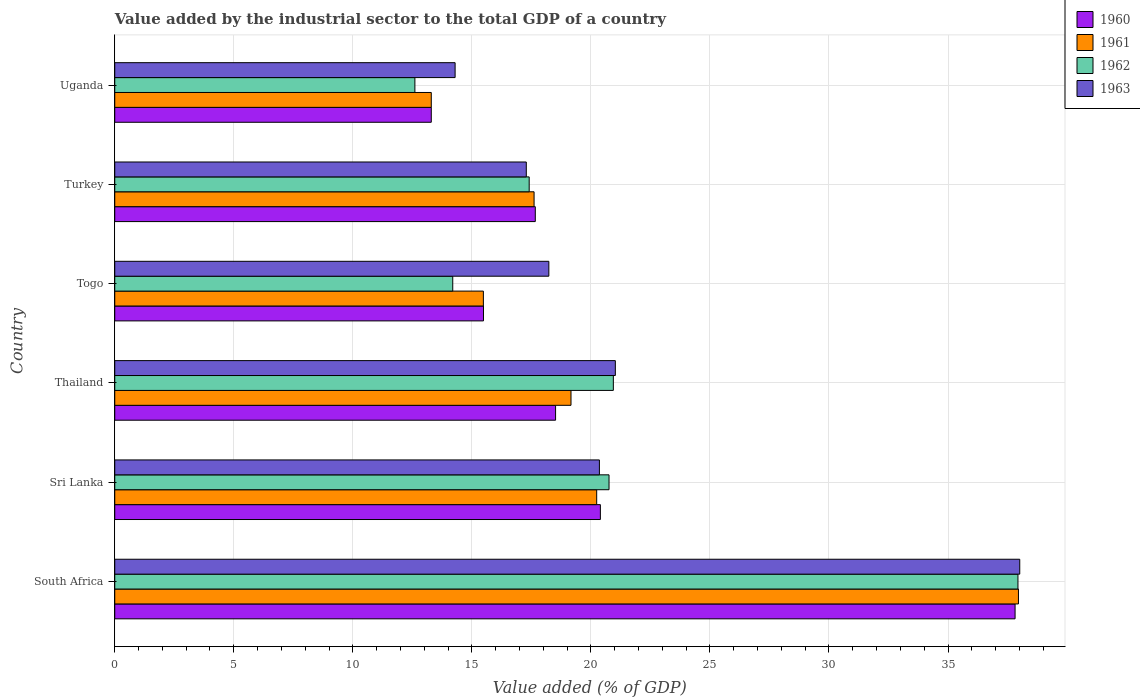How many different coloured bars are there?
Your response must be concise. 4. How many groups of bars are there?
Your answer should be compact. 6. Are the number of bars per tick equal to the number of legend labels?
Your answer should be very brief. Yes. How many bars are there on the 4th tick from the bottom?
Give a very brief answer. 4. What is the label of the 5th group of bars from the top?
Give a very brief answer. Sri Lanka. What is the value added by the industrial sector to the total GDP in 1962 in Thailand?
Your answer should be very brief. 20.94. Across all countries, what is the maximum value added by the industrial sector to the total GDP in 1961?
Provide a succinct answer. 37.96. Across all countries, what is the minimum value added by the industrial sector to the total GDP in 1960?
Your response must be concise. 13.3. In which country was the value added by the industrial sector to the total GDP in 1962 maximum?
Ensure brevity in your answer.  South Africa. In which country was the value added by the industrial sector to the total GDP in 1961 minimum?
Provide a short and direct response. Uganda. What is the total value added by the industrial sector to the total GDP in 1963 in the graph?
Give a very brief answer. 129.21. What is the difference between the value added by the industrial sector to the total GDP in 1962 in South Africa and that in Sri Lanka?
Your answer should be compact. 17.18. What is the difference between the value added by the industrial sector to the total GDP in 1960 in Sri Lanka and the value added by the industrial sector to the total GDP in 1961 in South Africa?
Ensure brevity in your answer.  -17.56. What is the average value added by the industrial sector to the total GDP in 1960 per country?
Your answer should be compact. 20.53. What is the difference between the value added by the industrial sector to the total GDP in 1963 and value added by the industrial sector to the total GDP in 1962 in Togo?
Provide a short and direct response. 4.04. What is the ratio of the value added by the industrial sector to the total GDP in 1963 in Thailand to that in Uganda?
Offer a very short reply. 1.47. What is the difference between the highest and the second highest value added by the industrial sector to the total GDP in 1962?
Ensure brevity in your answer.  17. What is the difference between the highest and the lowest value added by the industrial sector to the total GDP in 1962?
Your answer should be very brief. 25.33. Is the sum of the value added by the industrial sector to the total GDP in 1960 in South Africa and Thailand greater than the maximum value added by the industrial sector to the total GDP in 1962 across all countries?
Ensure brevity in your answer.  Yes. Is it the case that in every country, the sum of the value added by the industrial sector to the total GDP in 1960 and value added by the industrial sector to the total GDP in 1963 is greater than the sum of value added by the industrial sector to the total GDP in 1962 and value added by the industrial sector to the total GDP in 1961?
Your answer should be compact. No. What does the 2nd bar from the bottom in Turkey represents?
Your response must be concise. 1961. Is it the case that in every country, the sum of the value added by the industrial sector to the total GDP in 1961 and value added by the industrial sector to the total GDP in 1963 is greater than the value added by the industrial sector to the total GDP in 1960?
Make the answer very short. Yes. How many bars are there?
Your response must be concise. 24. Are all the bars in the graph horizontal?
Your answer should be compact. Yes. How many countries are there in the graph?
Make the answer very short. 6. Are the values on the major ticks of X-axis written in scientific E-notation?
Make the answer very short. No. Does the graph contain grids?
Provide a short and direct response. Yes. How are the legend labels stacked?
Ensure brevity in your answer.  Vertical. What is the title of the graph?
Your answer should be compact. Value added by the industrial sector to the total GDP of a country. What is the label or title of the X-axis?
Your response must be concise. Value added (% of GDP). What is the label or title of the Y-axis?
Your answer should be compact. Country. What is the Value added (% of GDP) in 1960 in South Africa?
Give a very brief answer. 37.82. What is the Value added (% of GDP) in 1961 in South Africa?
Your response must be concise. 37.96. What is the Value added (% of GDP) in 1962 in South Africa?
Give a very brief answer. 37.94. What is the Value added (% of GDP) in 1963 in South Africa?
Your answer should be compact. 38.01. What is the Value added (% of GDP) in 1960 in Sri Lanka?
Your answer should be compact. 20.4. What is the Value added (% of GDP) in 1961 in Sri Lanka?
Your answer should be compact. 20.24. What is the Value added (% of GDP) in 1962 in Sri Lanka?
Make the answer very short. 20.76. What is the Value added (% of GDP) in 1963 in Sri Lanka?
Offer a terse response. 20.36. What is the Value added (% of GDP) in 1960 in Thailand?
Give a very brief answer. 18.52. What is the Value added (% of GDP) of 1961 in Thailand?
Offer a terse response. 19.16. What is the Value added (% of GDP) in 1962 in Thailand?
Give a very brief answer. 20.94. What is the Value added (% of GDP) in 1963 in Thailand?
Ensure brevity in your answer.  21.03. What is the Value added (% of GDP) of 1960 in Togo?
Your answer should be very brief. 15.49. What is the Value added (% of GDP) in 1961 in Togo?
Keep it short and to the point. 15.48. What is the Value added (% of GDP) of 1962 in Togo?
Provide a succinct answer. 14.2. What is the Value added (% of GDP) in 1963 in Togo?
Offer a terse response. 18.23. What is the Value added (% of GDP) of 1960 in Turkey?
Your response must be concise. 17.66. What is the Value added (% of GDP) of 1961 in Turkey?
Provide a succinct answer. 17.61. What is the Value added (% of GDP) of 1962 in Turkey?
Keep it short and to the point. 17.41. What is the Value added (% of GDP) of 1963 in Turkey?
Offer a terse response. 17.29. What is the Value added (% of GDP) in 1960 in Uganda?
Make the answer very short. 13.3. What is the Value added (% of GDP) in 1961 in Uganda?
Offer a very short reply. 13.3. What is the Value added (% of GDP) of 1962 in Uganda?
Offer a very short reply. 12.61. What is the Value added (% of GDP) of 1963 in Uganda?
Your answer should be very brief. 14.3. Across all countries, what is the maximum Value added (% of GDP) in 1960?
Offer a very short reply. 37.82. Across all countries, what is the maximum Value added (% of GDP) in 1961?
Give a very brief answer. 37.96. Across all countries, what is the maximum Value added (% of GDP) in 1962?
Offer a very short reply. 37.94. Across all countries, what is the maximum Value added (% of GDP) of 1963?
Provide a succinct answer. 38.01. Across all countries, what is the minimum Value added (% of GDP) of 1960?
Provide a short and direct response. 13.3. Across all countries, what is the minimum Value added (% of GDP) of 1961?
Ensure brevity in your answer.  13.3. Across all countries, what is the minimum Value added (% of GDP) of 1962?
Provide a short and direct response. 12.61. Across all countries, what is the minimum Value added (% of GDP) of 1963?
Keep it short and to the point. 14.3. What is the total Value added (% of GDP) in 1960 in the graph?
Your response must be concise. 123.18. What is the total Value added (% of GDP) of 1961 in the graph?
Your answer should be very brief. 123.76. What is the total Value added (% of GDP) in 1962 in the graph?
Your response must be concise. 123.86. What is the total Value added (% of GDP) of 1963 in the graph?
Offer a terse response. 129.21. What is the difference between the Value added (% of GDP) in 1960 in South Africa and that in Sri Lanka?
Keep it short and to the point. 17.42. What is the difference between the Value added (% of GDP) in 1961 in South Africa and that in Sri Lanka?
Give a very brief answer. 17.72. What is the difference between the Value added (% of GDP) of 1962 in South Africa and that in Sri Lanka?
Provide a succinct answer. 17.18. What is the difference between the Value added (% of GDP) of 1963 in South Africa and that in Sri Lanka?
Your answer should be very brief. 17.66. What is the difference between the Value added (% of GDP) of 1960 in South Africa and that in Thailand?
Provide a short and direct response. 19.3. What is the difference between the Value added (% of GDP) of 1961 in South Africa and that in Thailand?
Make the answer very short. 18.79. What is the difference between the Value added (% of GDP) in 1962 in South Africa and that in Thailand?
Offer a terse response. 17. What is the difference between the Value added (% of GDP) of 1963 in South Africa and that in Thailand?
Provide a short and direct response. 16.99. What is the difference between the Value added (% of GDP) of 1960 in South Africa and that in Togo?
Provide a succinct answer. 22.33. What is the difference between the Value added (% of GDP) in 1961 in South Africa and that in Togo?
Keep it short and to the point. 22.48. What is the difference between the Value added (% of GDP) in 1962 in South Africa and that in Togo?
Provide a succinct answer. 23.74. What is the difference between the Value added (% of GDP) of 1963 in South Africa and that in Togo?
Offer a terse response. 19.78. What is the difference between the Value added (% of GDP) of 1960 in South Africa and that in Turkey?
Your answer should be very brief. 20.15. What is the difference between the Value added (% of GDP) in 1961 in South Africa and that in Turkey?
Offer a very short reply. 20.35. What is the difference between the Value added (% of GDP) of 1962 in South Africa and that in Turkey?
Keep it short and to the point. 20.53. What is the difference between the Value added (% of GDP) of 1963 in South Africa and that in Turkey?
Your response must be concise. 20.73. What is the difference between the Value added (% of GDP) of 1960 in South Africa and that in Uganda?
Keep it short and to the point. 24.52. What is the difference between the Value added (% of GDP) in 1961 in South Africa and that in Uganda?
Ensure brevity in your answer.  24.66. What is the difference between the Value added (% of GDP) of 1962 in South Africa and that in Uganda?
Provide a succinct answer. 25.33. What is the difference between the Value added (% of GDP) of 1963 in South Africa and that in Uganda?
Ensure brevity in your answer.  23.72. What is the difference between the Value added (% of GDP) of 1960 in Sri Lanka and that in Thailand?
Make the answer very short. 1.88. What is the difference between the Value added (% of GDP) in 1961 in Sri Lanka and that in Thailand?
Your answer should be very brief. 1.08. What is the difference between the Value added (% of GDP) of 1962 in Sri Lanka and that in Thailand?
Ensure brevity in your answer.  -0.18. What is the difference between the Value added (% of GDP) in 1963 in Sri Lanka and that in Thailand?
Offer a terse response. -0.67. What is the difference between the Value added (% of GDP) of 1960 in Sri Lanka and that in Togo?
Keep it short and to the point. 4.91. What is the difference between the Value added (% of GDP) in 1961 in Sri Lanka and that in Togo?
Offer a terse response. 4.76. What is the difference between the Value added (% of GDP) in 1962 in Sri Lanka and that in Togo?
Offer a very short reply. 6.56. What is the difference between the Value added (% of GDP) in 1963 in Sri Lanka and that in Togo?
Offer a very short reply. 2.12. What is the difference between the Value added (% of GDP) in 1960 in Sri Lanka and that in Turkey?
Your answer should be compact. 2.73. What is the difference between the Value added (% of GDP) of 1961 in Sri Lanka and that in Turkey?
Make the answer very short. 2.63. What is the difference between the Value added (% of GDP) of 1962 in Sri Lanka and that in Turkey?
Your answer should be compact. 3.35. What is the difference between the Value added (% of GDP) of 1963 in Sri Lanka and that in Turkey?
Offer a very short reply. 3.07. What is the difference between the Value added (% of GDP) in 1960 in Sri Lanka and that in Uganda?
Provide a succinct answer. 7.1. What is the difference between the Value added (% of GDP) of 1961 in Sri Lanka and that in Uganda?
Your response must be concise. 6.95. What is the difference between the Value added (% of GDP) in 1962 in Sri Lanka and that in Uganda?
Offer a terse response. 8.15. What is the difference between the Value added (% of GDP) in 1963 in Sri Lanka and that in Uganda?
Ensure brevity in your answer.  6.06. What is the difference between the Value added (% of GDP) in 1960 in Thailand and that in Togo?
Provide a short and direct response. 3.03. What is the difference between the Value added (% of GDP) of 1961 in Thailand and that in Togo?
Provide a short and direct response. 3.68. What is the difference between the Value added (% of GDP) of 1962 in Thailand and that in Togo?
Keep it short and to the point. 6.75. What is the difference between the Value added (% of GDP) in 1963 in Thailand and that in Togo?
Ensure brevity in your answer.  2.79. What is the difference between the Value added (% of GDP) in 1960 in Thailand and that in Turkey?
Offer a very short reply. 0.85. What is the difference between the Value added (% of GDP) in 1961 in Thailand and that in Turkey?
Your answer should be very brief. 1.55. What is the difference between the Value added (% of GDP) in 1962 in Thailand and that in Turkey?
Make the answer very short. 3.54. What is the difference between the Value added (% of GDP) of 1963 in Thailand and that in Turkey?
Ensure brevity in your answer.  3.74. What is the difference between the Value added (% of GDP) of 1960 in Thailand and that in Uganda?
Provide a succinct answer. 5.22. What is the difference between the Value added (% of GDP) in 1961 in Thailand and that in Uganda?
Give a very brief answer. 5.87. What is the difference between the Value added (% of GDP) of 1962 in Thailand and that in Uganda?
Your answer should be very brief. 8.34. What is the difference between the Value added (% of GDP) in 1963 in Thailand and that in Uganda?
Give a very brief answer. 6.73. What is the difference between the Value added (% of GDP) in 1960 in Togo and that in Turkey?
Ensure brevity in your answer.  -2.18. What is the difference between the Value added (% of GDP) in 1961 in Togo and that in Turkey?
Offer a very short reply. -2.13. What is the difference between the Value added (% of GDP) in 1962 in Togo and that in Turkey?
Provide a succinct answer. -3.21. What is the difference between the Value added (% of GDP) in 1963 in Togo and that in Turkey?
Your response must be concise. 0.95. What is the difference between the Value added (% of GDP) of 1960 in Togo and that in Uganda?
Give a very brief answer. 2.19. What is the difference between the Value added (% of GDP) in 1961 in Togo and that in Uganda?
Make the answer very short. 2.19. What is the difference between the Value added (% of GDP) in 1962 in Togo and that in Uganda?
Provide a short and direct response. 1.59. What is the difference between the Value added (% of GDP) in 1963 in Togo and that in Uganda?
Provide a short and direct response. 3.94. What is the difference between the Value added (% of GDP) in 1960 in Turkey and that in Uganda?
Your response must be concise. 4.37. What is the difference between the Value added (% of GDP) of 1961 in Turkey and that in Uganda?
Give a very brief answer. 4.32. What is the difference between the Value added (% of GDP) of 1962 in Turkey and that in Uganda?
Your answer should be compact. 4.8. What is the difference between the Value added (% of GDP) of 1963 in Turkey and that in Uganda?
Give a very brief answer. 2.99. What is the difference between the Value added (% of GDP) in 1960 in South Africa and the Value added (% of GDP) in 1961 in Sri Lanka?
Offer a terse response. 17.57. What is the difference between the Value added (% of GDP) of 1960 in South Africa and the Value added (% of GDP) of 1962 in Sri Lanka?
Make the answer very short. 17.06. What is the difference between the Value added (% of GDP) of 1960 in South Africa and the Value added (% of GDP) of 1963 in Sri Lanka?
Offer a very short reply. 17.46. What is the difference between the Value added (% of GDP) of 1961 in South Africa and the Value added (% of GDP) of 1962 in Sri Lanka?
Give a very brief answer. 17.2. What is the difference between the Value added (% of GDP) of 1961 in South Africa and the Value added (% of GDP) of 1963 in Sri Lanka?
Your response must be concise. 17.6. What is the difference between the Value added (% of GDP) of 1962 in South Africa and the Value added (% of GDP) of 1963 in Sri Lanka?
Make the answer very short. 17.58. What is the difference between the Value added (% of GDP) in 1960 in South Africa and the Value added (% of GDP) in 1961 in Thailand?
Ensure brevity in your answer.  18.65. What is the difference between the Value added (% of GDP) in 1960 in South Africa and the Value added (% of GDP) in 1962 in Thailand?
Your response must be concise. 16.87. What is the difference between the Value added (% of GDP) of 1960 in South Africa and the Value added (% of GDP) of 1963 in Thailand?
Provide a short and direct response. 16.79. What is the difference between the Value added (% of GDP) in 1961 in South Africa and the Value added (% of GDP) in 1962 in Thailand?
Keep it short and to the point. 17.02. What is the difference between the Value added (% of GDP) in 1961 in South Africa and the Value added (% of GDP) in 1963 in Thailand?
Your response must be concise. 16.93. What is the difference between the Value added (% of GDP) in 1962 in South Africa and the Value added (% of GDP) in 1963 in Thailand?
Your answer should be compact. 16.91. What is the difference between the Value added (% of GDP) of 1960 in South Africa and the Value added (% of GDP) of 1961 in Togo?
Your response must be concise. 22.33. What is the difference between the Value added (% of GDP) in 1960 in South Africa and the Value added (% of GDP) in 1962 in Togo?
Your answer should be compact. 23.62. What is the difference between the Value added (% of GDP) of 1960 in South Africa and the Value added (% of GDP) of 1963 in Togo?
Keep it short and to the point. 19.58. What is the difference between the Value added (% of GDP) of 1961 in South Africa and the Value added (% of GDP) of 1962 in Togo?
Provide a succinct answer. 23.76. What is the difference between the Value added (% of GDP) in 1961 in South Africa and the Value added (% of GDP) in 1963 in Togo?
Keep it short and to the point. 19.73. What is the difference between the Value added (% of GDP) of 1962 in South Africa and the Value added (% of GDP) of 1963 in Togo?
Offer a very short reply. 19.7. What is the difference between the Value added (% of GDP) of 1960 in South Africa and the Value added (% of GDP) of 1961 in Turkey?
Provide a short and direct response. 20.2. What is the difference between the Value added (% of GDP) in 1960 in South Africa and the Value added (% of GDP) in 1962 in Turkey?
Provide a succinct answer. 20.41. What is the difference between the Value added (% of GDP) in 1960 in South Africa and the Value added (% of GDP) in 1963 in Turkey?
Offer a terse response. 20.53. What is the difference between the Value added (% of GDP) in 1961 in South Africa and the Value added (% of GDP) in 1962 in Turkey?
Your answer should be compact. 20.55. What is the difference between the Value added (% of GDP) of 1961 in South Africa and the Value added (% of GDP) of 1963 in Turkey?
Ensure brevity in your answer.  20.67. What is the difference between the Value added (% of GDP) in 1962 in South Africa and the Value added (% of GDP) in 1963 in Turkey?
Your response must be concise. 20.65. What is the difference between the Value added (% of GDP) of 1960 in South Africa and the Value added (% of GDP) of 1961 in Uganda?
Offer a terse response. 24.52. What is the difference between the Value added (% of GDP) of 1960 in South Africa and the Value added (% of GDP) of 1962 in Uganda?
Provide a succinct answer. 25.21. What is the difference between the Value added (% of GDP) in 1960 in South Africa and the Value added (% of GDP) in 1963 in Uganda?
Your answer should be compact. 23.52. What is the difference between the Value added (% of GDP) of 1961 in South Africa and the Value added (% of GDP) of 1962 in Uganda?
Offer a terse response. 25.35. What is the difference between the Value added (% of GDP) in 1961 in South Africa and the Value added (% of GDP) in 1963 in Uganda?
Keep it short and to the point. 23.66. What is the difference between the Value added (% of GDP) of 1962 in South Africa and the Value added (% of GDP) of 1963 in Uganda?
Offer a terse response. 23.64. What is the difference between the Value added (% of GDP) of 1960 in Sri Lanka and the Value added (% of GDP) of 1961 in Thailand?
Offer a terse response. 1.23. What is the difference between the Value added (% of GDP) of 1960 in Sri Lanka and the Value added (% of GDP) of 1962 in Thailand?
Offer a terse response. -0.54. What is the difference between the Value added (% of GDP) of 1960 in Sri Lanka and the Value added (% of GDP) of 1963 in Thailand?
Offer a very short reply. -0.63. What is the difference between the Value added (% of GDP) of 1961 in Sri Lanka and the Value added (% of GDP) of 1962 in Thailand?
Offer a very short reply. -0.7. What is the difference between the Value added (% of GDP) in 1961 in Sri Lanka and the Value added (% of GDP) in 1963 in Thailand?
Provide a short and direct response. -0.78. What is the difference between the Value added (% of GDP) of 1962 in Sri Lanka and the Value added (% of GDP) of 1963 in Thailand?
Give a very brief answer. -0.27. What is the difference between the Value added (% of GDP) in 1960 in Sri Lanka and the Value added (% of GDP) in 1961 in Togo?
Keep it short and to the point. 4.91. What is the difference between the Value added (% of GDP) in 1960 in Sri Lanka and the Value added (% of GDP) in 1962 in Togo?
Your answer should be compact. 6.2. What is the difference between the Value added (% of GDP) of 1960 in Sri Lanka and the Value added (% of GDP) of 1963 in Togo?
Your response must be concise. 2.16. What is the difference between the Value added (% of GDP) of 1961 in Sri Lanka and the Value added (% of GDP) of 1962 in Togo?
Make the answer very short. 6.05. What is the difference between the Value added (% of GDP) of 1961 in Sri Lanka and the Value added (% of GDP) of 1963 in Togo?
Make the answer very short. 2.01. What is the difference between the Value added (% of GDP) in 1962 in Sri Lanka and the Value added (% of GDP) in 1963 in Togo?
Ensure brevity in your answer.  2.53. What is the difference between the Value added (% of GDP) in 1960 in Sri Lanka and the Value added (% of GDP) in 1961 in Turkey?
Your response must be concise. 2.78. What is the difference between the Value added (% of GDP) in 1960 in Sri Lanka and the Value added (% of GDP) in 1962 in Turkey?
Provide a succinct answer. 2.99. What is the difference between the Value added (% of GDP) of 1960 in Sri Lanka and the Value added (% of GDP) of 1963 in Turkey?
Your response must be concise. 3.11. What is the difference between the Value added (% of GDP) of 1961 in Sri Lanka and the Value added (% of GDP) of 1962 in Turkey?
Make the answer very short. 2.84. What is the difference between the Value added (% of GDP) in 1961 in Sri Lanka and the Value added (% of GDP) in 1963 in Turkey?
Your answer should be very brief. 2.96. What is the difference between the Value added (% of GDP) of 1962 in Sri Lanka and the Value added (% of GDP) of 1963 in Turkey?
Offer a very short reply. 3.48. What is the difference between the Value added (% of GDP) of 1960 in Sri Lanka and the Value added (% of GDP) of 1961 in Uganda?
Keep it short and to the point. 7.1. What is the difference between the Value added (% of GDP) in 1960 in Sri Lanka and the Value added (% of GDP) in 1962 in Uganda?
Ensure brevity in your answer.  7.79. What is the difference between the Value added (% of GDP) in 1960 in Sri Lanka and the Value added (% of GDP) in 1963 in Uganda?
Offer a terse response. 6.1. What is the difference between the Value added (% of GDP) of 1961 in Sri Lanka and the Value added (% of GDP) of 1962 in Uganda?
Offer a terse response. 7.64. What is the difference between the Value added (% of GDP) of 1961 in Sri Lanka and the Value added (% of GDP) of 1963 in Uganda?
Keep it short and to the point. 5.95. What is the difference between the Value added (% of GDP) of 1962 in Sri Lanka and the Value added (% of GDP) of 1963 in Uganda?
Provide a succinct answer. 6.47. What is the difference between the Value added (% of GDP) in 1960 in Thailand and the Value added (% of GDP) in 1961 in Togo?
Your answer should be very brief. 3.03. What is the difference between the Value added (% of GDP) in 1960 in Thailand and the Value added (% of GDP) in 1962 in Togo?
Ensure brevity in your answer.  4.32. What is the difference between the Value added (% of GDP) of 1960 in Thailand and the Value added (% of GDP) of 1963 in Togo?
Your answer should be very brief. 0.28. What is the difference between the Value added (% of GDP) of 1961 in Thailand and the Value added (% of GDP) of 1962 in Togo?
Offer a very short reply. 4.97. What is the difference between the Value added (% of GDP) in 1961 in Thailand and the Value added (% of GDP) in 1963 in Togo?
Provide a short and direct response. 0.93. What is the difference between the Value added (% of GDP) in 1962 in Thailand and the Value added (% of GDP) in 1963 in Togo?
Your answer should be compact. 2.71. What is the difference between the Value added (% of GDP) of 1960 in Thailand and the Value added (% of GDP) of 1961 in Turkey?
Ensure brevity in your answer.  0.9. What is the difference between the Value added (% of GDP) of 1960 in Thailand and the Value added (% of GDP) of 1962 in Turkey?
Provide a short and direct response. 1.11. What is the difference between the Value added (% of GDP) of 1960 in Thailand and the Value added (% of GDP) of 1963 in Turkey?
Offer a very short reply. 1.23. What is the difference between the Value added (% of GDP) in 1961 in Thailand and the Value added (% of GDP) in 1962 in Turkey?
Your answer should be very brief. 1.76. What is the difference between the Value added (% of GDP) of 1961 in Thailand and the Value added (% of GDP) of 1963 in Turkey?
Keep it short and to the point. 1.88. What is the difference between the Value added (% of GDP) in 1962 in Thailand and the Value added (% of GDP) in 1963 in Turkey?
Your response must be concise. 3.66. What is the difference between the Value added (% of GDP) of 1960 in Thailand and the Value added (% of GDP) of 1961 in Uganda?
Your response must be concise. 5.22. What is the difference between the Value added (% of GDP) in 1960 in Thailand and the Value added (% of GDP) in 1962 in Uganda?
Offer a very short reply. 5.91. What is the difference between the Value added (% of GDP) of 1960 in Thailand and the Value added (% of GDP) of 1963 in Uganda?
Your answer should be very brief. 4.22. What is the difference between the Value added (% of GDP) in 1961 in Thailand and the Value added (% of GDP) in 1962 in Uganda?
Ensure brevity in your answer.  6.56. What is the difference between the Value added (% of GDP) in 1961 in Thailand and the Value added (% of GDP) in 1963 in Uganda?
Your answer should be compact. 4.87. What is the difference between the Value added (% of GDP) of 1962 in Thailand and the Value added (% of GDP) of 1963 in Uganda?
Give a very brief answer. 6.65. What is the difference between the Value added (% of GDP) in 1960 in Togo and the Value added (% of GDP) in 1961 in Turkey?
Provide a succinct answer. -2.13. What is the difference between the Value added (% of GDP) in 1960 in Togo and the Value added (% of GDP) in 1962 in Turkey?
Your response must be concise. -1.92. What is the difference between the Value added (% of GDP) in 1960 in Togo and the Value added (% of GDP) in 1963 in Turkey?
Offer a terse response. -1.8. What is the difference between the Value added (% of GDP) of 1961 in Togo and the Value added (% of GDP) of 1962 in Turkey?
Offer a very short reply. -1.92. What is the difference between the Value added (% of GDP) of 1961 in Togo and the Value added (% of GDP) of 1963 in Turkey?
Keep it short and to the point. -1.8. What is the difference between the Value added (% of GDP) of 1962 in Togo and the Value added (% of GDP) of 1963 in Turkey?
Keep it short and to the point. -3.09. What is the difference between the Value added (% of GDP) in 1960 in Togo and the Value added (% of GDP) in 1961 in Uganda?
Provide a short and direct response. 2.19. What is the difference between the Value added (% of GDP) of 1960 in Togo and the Value added (% of GDP) of 1962 in Uganda?
Keep it short and to the point. 2.88. What is the difference between the Value added (% of GDP) in 1960 in Togo and the Value added (% of GDP) in 1963 in Uganda?
Keep it short and to the point. 1.19. What is the difference between the Value added (% of GDP) in 1961 in Togo and the Value added (% of GDP) in 1962 in Uganda?
Make the answer very short. 2.88. What is the difference between the Value added (% of GDP) of 1961 in Togo and the Value added (% of GDP) of 1963 in Uganda?
Your answer should be very brief. 1.19. What is the difference between the Value added (% of GDP) of 1962 in Togo and the Value added (% of GDP) of 1963 in Uganda?
Make the answer very short. -0.1. What is the difference between the Value added (% of GDP) of 1960 in Turkey and the Value added (% of GDP) of 1961 in Uganda?
Keep it short and to the point. 4.37. What is the difference between the Value added (% of GDP) of 1960 in Turkey and the Value added (% of GDP) of 1962 in Uganda?
Give a very brief answer. 5.06. What is the difference between the Value added (% of GDP) in 1960 in Turkey and the Value added (% of GDP) in 1963 in Uganda?
Give a very brief answer. 3.37. What is the difference between the Value added (% of GDP) in 1961 in Turkey and the Value added (% of GDP) in 1962 in Uganda?
Provide a succinct answer. 5.01. What is the difference between the Value added (% of GDP) in 1961 in Turkey and the Value added (% of GDP) in 1963 in Uganda?
Provide a short and direct response. 3.32. What is the difference between the Value added (% of GDP) of 1962 in Turkey and the Value added (% of GDP) of 1963 in Uganda?
Make the answer very short. 3.11. What is the average Value added (% of GDP) in 1960 per country?
Your response must be concise. 20.53. What is the average Value added (% of GDP) in 1961 per country?
Make the answer very short. 20.63. What is the average Value added (% of GDP) of 1962 per country?
Provide a succinct answer. 20.64. What is the average Value added (% of GDP) of 1963 per country?
Keep it short and to the point. 21.54. What is the difference between the Value added (% of GDP) in 1960 and Value added (% of GDP) in 1961 in South Africa?
Make the answer very short. -0.14. What is the difference between the Value added (% of GDP) in 1960 and Value added (% of GDP) in 1962 in South Africa?
Keep it short and to the point. -0.12. What is the difference between the Value added (% of GDP) of 1960 and Value added (% of GDP) of 1963 in South Africa?
Ensure brevity in your answer.  -0.2. What is the difference between the Value added (% of GDP) of 1961 and Value added (% of GDP) of 1962 in South Africa?
Ensure brevity in your answer.  0.02. What is the difference between the Value added (% of GDP) in 1961 and Value added (% of GDP) in 1963 in South Africa?
Offer a terse response. -0.05. What is the difference between the Value added (% of GDP) in 1962 and Value added (% of GDP) in 1963 in South Africa?
Ensure brevity in your answer.  -0.08. What is the difference between the Value added (% of GDP) of 1960 and Value added (% of GDP) of 1961 in Sri Lanka?
Provide a succinct answer. 0.16. What is the difference between the Value added (% of GDP) in 1960 and Value added (% of GDP) in 1962 in Sri Lanka?
Offer a very short reply. -0.36. What is the difference between the Value added (% of GDP) in 1960 and Value added (% of GDP) in 1963 in Sri Lanka?
Your answer should be very brief. 0.04. What is the difference between the Value added (% of GDP) in 1961 and Value added (% of GDP) in 1962 in Sri Lanka?
Offer a very short reply. -0.52. What is the difference between the Value added (% of GDP) of 1961 and Value added (% of GDP) of 1963 in Sri Lanka?
Your answer should be very brief. -0.11. What is the difference between the Value added (% of GDP) of 1962 and Value added (% of GDP) of 1963 in Sri Lanka?
Provide a succinct answer. 0.4. What is the difference between the Value added (% of GDP) in 1960 and Value added (% of GDP) in 1961 in Thailand?
Ensure brevity in your answer.  -0.65. What is the difference between the Value added (% of GDP) of 1960 and Value added (% of GDP) of 1962 in Thailand?
Your answer should be very brief. -2.43. What is the difference between the Value added (% of GDP) of 1960 and Value added (% of GDP) of 1963 in Thailand?
Your answer should be compact. -2.51. What is the difference between the Value added (% of GDP) of 1961 and Value added (% of GDP) of 1962 in Thailand?
Offer a very short reply. -1.78. What is the difference between the Value added (% of GDP) in 1961 and Value added (% of GDP) in 1963 in Thailand?
Provide a succinct answer. -1.86. What is the difference between the Value added (% of GDP) in 1962 and Value added (% of GDP) in 1963 in Thailand?
Provide a succinct answer. -0.08. What is the difference between the Value added (% of GDP) of 1960 and Value added (% of GDP) of 1961 in Togo?
Provide a short and direct response. 0. What is the difference between the Value added (% of GDP) of 1960 and Value added (% of GDP) of 1962 in Togo?
Your answer should be very brief. 1.29. What is the difference between the Value added (% of GDP) of 1960 and Value added (% of GDP) of 1963 in Togo?
Your answer should be compact. -2.75. What is the difference between the Value added (% of GDP) of 1961 and Value added (% of GDP) of 1962 in Togo?
Your response must be concise. 1.29. What is the difference between the Value added (% of GDP) of 1961 and Value added (% of GDP) of 1963 in Togo?
Give a very brief answer. -2.75. What is the difference between the Value added (% of GDP) in 1962 and Value added (% of GDP) in 1963 in Togo?
Ensure brevity in your answer.  -4.04. What is the difference between the Value added (% of GDP) of 1960 and Value added (% of GDP) of 1961 in Turkey?
Offer a very short reply. 0.05. What is the difference between the Value added (% of GDP) of 1960 and Value added (% of GDP) of 1962 in Turkey?
Your response must be concise. 0.26. What is the difference between the Value added (% of GDP) in 1960 and Value added (% of GDP) in 1963 in Turkey?
Provide a short and direct response. 0.38. What is the difference between the Value added (% of GDP) of 1961 and Value added (% of GDP) of 1962 in Turkey?
Give a very brief answer. 0.21. What is the difference between the Value added (% of GDP) of 1961 and Value added (% of GDP) of 1963 in Turkey?
Provide a short and direct response. 0.33. What is the difference between the Value added (% of GDP) in 1962 and Value added (% of GDP) in 1963 in Turkey?
Offer a terse response. 0.12. What is the difference between the Value added (% of GDP) in 1960 and Value added (% of GDP) in 1961 in Uganda?
Give a very brief answer. -0. What is the difference between the Value added (% of GDP) in 1960 and Value added (% of GDP) in 1962 in Uganda?
Keep it short and to the point. 0.69. What is the difference between the Value added (% of GDP) in 1960 and Value added (% of GDP) in 1963 in Uganda?
Make the answer very short. -1. What is the difference between the Value added (% of GDP) in 1961 and Value added (% of GDP) in 1962 in Uganda?
Your answer should be very brief. 0.69. What is the difference between the Value added (% of GDP) of 1961 and Value added (% of GDP) of 1963 in Uganda?
Keep it short and to the point. -1. What is the difference between the Value added (% of GDP) of 1962 and Value added (% of GDP) of 1963 in Uganda?
Offer a very short reply. -1.69. What is the ratio of the Value added (% of GDP) of 1960 in South Africa to that in Sri Lanka?
Keep it short and to the point. 1.85. What is the ratio of the Value added (% of GDP) of 1961 in South Africa to that in Sri Lanka?
Offer a terse response. 1.88. What is the ratio of the Value added (% of GDP) in 1962 in South Africa to that in Sri Lanka?
Ensure brevity in your answer.  1.83. What is the ratio of the Value added (% of GDP) of 1963 in South Africa to that in Sri Lanka?
Keep it short and to the point. 1.87. What is the ratio of the Value added (% of GDP) of 1960 in South Africa to that in Thailand?
Your answer should be very brief. 2.04. What is the ratio of the Value added (% of GDP) in 1961 in South Africa to that in Thailand?
Give a very brief answer. 1.98. What is the ratio of the Value added (% of GDP) in 1962 in South Africa to that in Thailand?
Offer a very short reply. 1.81. What is the ratio of the Value added (% of GDP) of 1963 in South Africa to that in Thailand?
Provide a succinct answer. 1.81. What is the ratio of the Value added (% of GDP) of 1960 in South Africa to that in Togo?
Give a very brief answer. 2.44. What is the ratio of the Value added (% of GDP) of 1961 in South Africa to that in Togo?
Keep it short and to the point. 2.45. What is the ratio of the Value added (% of GDP) of 1962 in South Africa to that in Togo?
Your answer should be very brief. 2.67. What is the ratio of the Value added (% of GDP) in 1963 in South Africa to that in Togo?
Keep it short and to the point. 2.08. What is the ratio of the Value added (% of GDP) of 1960 in South Africa to that in Turkey?
Your response must be concise. 2.14. What is the ratio of the Value added (% of GDP) of 1961 in South Africa to that in Turkey?
Ensure brevity in your answer.  2.16. What is the ratio of the Value added (% of GDP) of 1962 in South Africa to that in Turkey?
Provide a succinct answer. 2.18. What is the ratio of the Value added (% of GDP) of 1963 in South Africa to that in Turkey?
Provide a succinct answer. 2.2. What is the ratio of the Value added (% of GDP) of 1960 in South Africa to that in Uganda?
Give a very brief answer. 2.84. What is the ratio of the Value added (% of GDP) in 1961 in South Africa to that in Uganda?
Make the answer very short. 2.86. What is the ratio of the Value added (% of GDP) of 1962 in South Africa to that in Uganda?
Offer a terse response. 3.01. What is the ratio of the Value added (% of GDP) in 1963 in South Africa to that in Uganda?
Offer a very short reply. 2.66. What is the ratio of the Value added (% of GDP) in 1960 in Sri Lanka to that in Thailand?
Offer a terse response. 1.1. What is the ratio of the Value added (% of GDP) of 1961 in Sri Lanka to that in Thailand?
Your response must be concise. 1.06. What is the ratio of the Value added (% of GDP) in 1962 in Sri Lanka to that in Thailand?
Make the answer very short. 0.99. What is the ratio of the Value added (% of GDP) of 1963 in Sri Lanka to that in Thailand?
Provide a short and direct response. 0.97. What is the ratio of the Value added (% of GDP) of 1960 in Sri Lanka to that in Togo?
Offer a terse response. 1.32. What is the ratio of the Value added (% of GDP) in 1961 in Sri Lanka to that in Togo?
Provide a succinct answer. 1.31. What is the ratio of the Value added (% of GDP) in 1962 in Sri Lanka to that in Togo?
Give a very brief answer. 1.46. What is the ratio of the Value added (% of GDP) of 1963 in Sri Lanka to that in Togo?
Ensure brevity in your answer.  1.12. What is the ratio of the Value added (% of GDP) of 1960 in Sri Lanka to that in Turkey?
Your response must be concise. 1.15. What is the ratio of the Value added (% of GDP) in 1961 in Sri Lanka to that in Turkey?
Your answer should be very brief. 1.15. What is the ratio of the Value added (% of GDP) in 1962 in Sri Lanka to that in Turkey?
Provide a succinct answer. 1.19. What is the ratio of the Value added (% of GDP) of 1963 in Sri Lanka to that in Turkey?
Your response must be concise. 1.18. What is the ratio of the Value added (% of GDP) of 1960 in Sri Lanka to that in Uganda?
Make the answer very short. 1.53. What is the ratio of the Value added (% of GDP) of 1961 in Sri Lanka to that in Uganda?
Your answer should be very brief. 1.52. What is the ratio of the Value added (% of GDP) of 1962 in Sri Lanka to that in Uganda?
Offer a very short reply. 1.65. What is the ratio of the Value added (% of GDP) of 1963 in Sri Lanka to that in Uganda?
Your answer should be compact. 1.42. What is the ratio of the Value added (% of GDP) in 1960 in Thailand to that in Togo?
Ensure brevity in your answer.  1.2. What is the ratio of the Value added (% of GDP) of 1961 in Thailand to that in Togo?
Provide a short and direct response. 1.24. What is the ratio of the Value added (% of GDP) of 1962 in Thailand to that in Togo?
Give a very brief answer. 1.48. What is the ratio of the Value added (% of GDP) of 1963 in Thailand to that in Togo?
Provide a short and direct response. 1.15. What is the ratio of the Value added (% of GDP) of 1960 in Thailand to that in Turkey?
Ensure brevity in your answer.  1.05. What is the ratio of the Value added (% of GDP) of 1961 in Thailand to that in Turkey?
Provide a short and direct response. 1.09. What is the ratio of the Value added (% of GDP) of 1962 in Thailand to that in Turkey?
Your answer should be very brief. 1.2. What is the ratio of the Value added (% of GDP) in 1963 in Thailand to that in Turkey?
Provide a short and direct response. 1.22. What is the ratio of the Value added (% of GDP) of 1960 in Thailand to that in Uganda?
Your response must be concise. 1.39. What is the ratio of the Value added (% of GDP) in 1961 in Thailand to that in Uganda?
Your answer should be compact. 1.44. What is the ratio of the Value added (% of GDP) in 1962 in Thailand to that in Uganda?
Make the answer very short. 1.66. What is the ratio of the Value added (% of GDP) in 1963 in Thailand to that in Uganda?
Make the answer very short. 1.47. What is the ratio of the Value added (% of GDP) in 1960 in Togo to that in Turkey?
Provide a short and direct response. 0.88. What is the ratio of the Value added (% of GDP) in 1961 in Togo to that in Turkey?
Offer a very short reply. 0.88. What is the ratio of the Value added (% of GDP) in 1962 in Togo to that in Turkey?
Offer a terse response. 0.82. What is the ratio of the Value added (% of GDP) in 1963 in Togo to that in Turkey?
Offer a terse response. 1.05. What is the ratio of the Value added (% of GDP) of 1960 in Togo to that in Uganda?
Provide a short and direct response. 1.16. What is the ratio of the Value added (% of GDP) in 1961 in Togo to that in Uganda?
Your response must be concise. 1.16. What is the ratio of the Value added (% of GDP) in 1962 in Togo to that in Uganda?
Provide a short and direct response. 1.13. What is the ratio of the Value added (% of GDP) in 1963 in Togo to that in Uganda?
Your response must be concise. 1.28. What is the ratio of the Value added (% of GDP) in 1960 in Turkey to that in Uganda?
Provide a short and direct response. 1.33. What is the ratio of the Value added (% of GDP) in 1961 in Turkey to that in Uganda?
Your response must be concise. 1.32. What is the ratio of the Value added (% of GDP) of 1962 in Turkey to that in Uganda?
Your response must be concise. 1.38. What is the ratio of the Value added (% of GDP) in 1963 in Turkey to that in Uganda?
Provide a short and direct response. 1.21. What is the difference between the highest and the second highest Value added (% of GDP) of 1960?
Your answer should be compact. 17.42. What is the difference between the highest and the second highest Value added (% of GDP) of 1961?
Give a very brief answer. 17.72. What is the difference between the highest and the second highest Value added (% of GDP) of 1962?
Provide a short and direct response. 17. What is the difference between the highest and the second highest Value added (% of GDP) in 1963?
Provide a succinct answer. 16.99. What is the difference between the highest and the lowest Value added (% of GDP) of 1960?
Your response must be concise. 24.52. What is the difference between the highest and the lowest Value added (% of GDP) in 1961?
Your answer should be very brief. 24.66. What is the difference between the highest and the lowest Value added (% of GDP) of 1962?
Give a very brief answer. 25.33. What is the difference between the highest and the lowest Value added (% of GDP) of 1963?
Give a very brief answer. 23.72. 